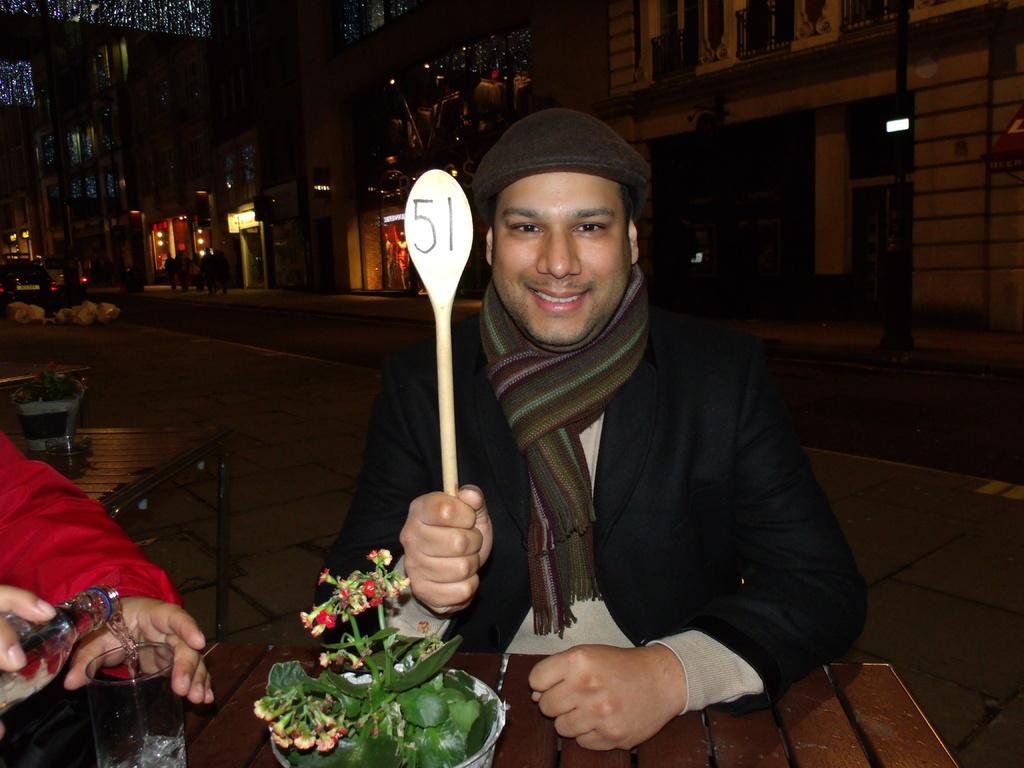Describe this image in one or two sentences. In this image I can see two people sitting in-front of the table. These people are wearing the red, cream and black color dresses. One person is holding the spoon and another one is holding the glass and bottle. There is a flower pot on the brown color table. In the back I can see few more people, building and the lights. 